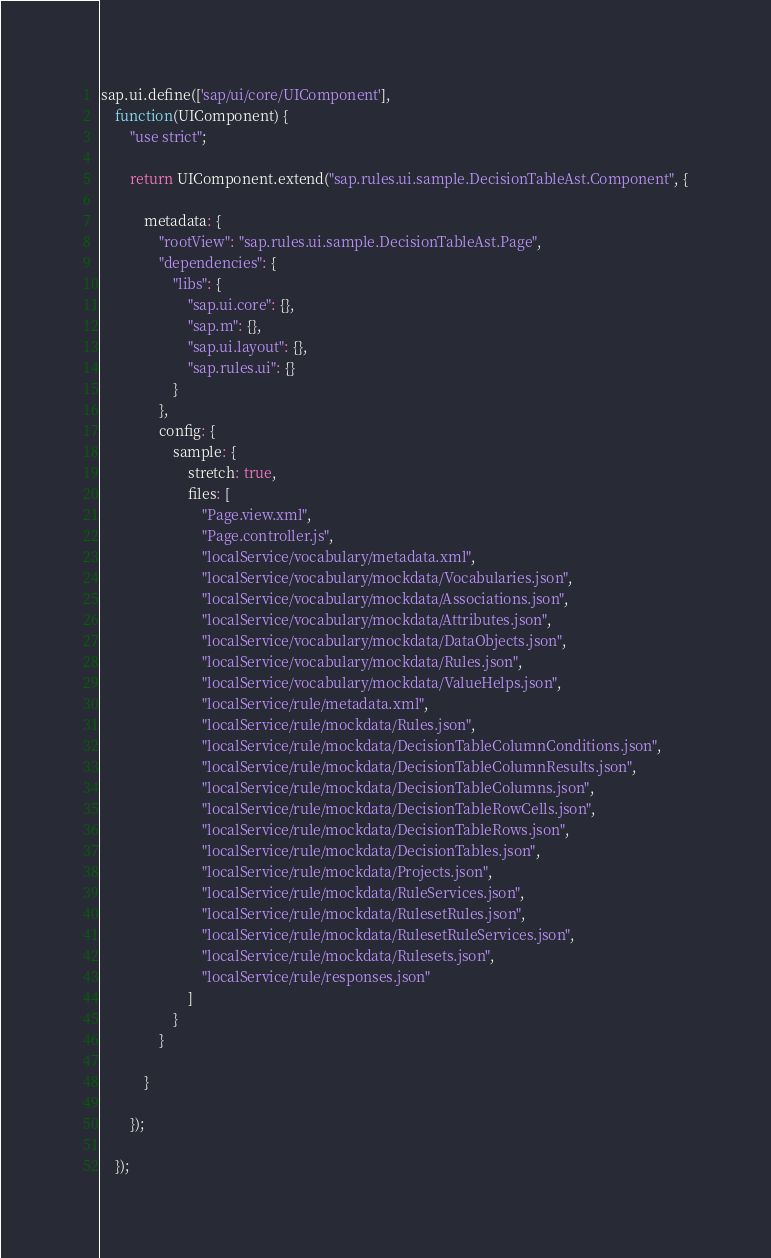<code> <loc_0><loc_0><loc_500><loc_500><_JavaScript_>sap.ui.define(['sap/ui/core/UIComponent'],
	function(UIComponent) {
		"use strict";

		return UIComponent.extend("sap.rules.ui.sample.DecisionTableAst.Component", {

			metadata: {
				"rootView": "sap.rules.ui.sample.DecisionTableAst.Page",
				"dependencies": {
					"libs": {
						"sap.ui.core": {},
						"sap.m": {},
						"sap.ui.layout": {},
						"sap.rules.ui": {}
					}
				},
				config: {
					sample: {
						stretch: true,
						files: [
							"Page.view.xml",
							"Page.controller.js",
							"localService/vocabulary/metadata.xml",
							"localService/vocabulary/mockdata/Vocabularies.json",
							"localService/vocabulary/mockdata/Associations.json",
							"localService/vocabulary/mockdata/Attributes.json",
							"localService/vocabulary/mockdata/DataObjects.json",
							"localService/vocabulary/mockdata/Rules.json",
							"localService/vocabulary/mockdata/ValueHelps.json",
							"localService/rule/metadata.xml",
							"localService/rule/mockdata/Rules.json",
							"localService/rule/mockdata/DecisionTableColumnConditions.json",
							"localService/rule/mockdata/DecisionTableColumnResults.json",
							"localService/rule/mockdata/DecisionTableColumns.json",
							"localService/rule/mockdata/DecisionTableRowCells.json",
							"localService/rule/mockdata/DecisionTableRows.json",
							"localService/rule/mockdata/DecisionTables.json",
							"localService/rule/mockdata/Projects.json",
							"localService/rule/mockdata/RuleServices.json",
							"localService/rule/mockdata/RulesetRules.json",
							"localService/rule/mockdata/RulesetRuleServices.json",
							"localService/rule/mockdata/Rulesets.json",
							"localService/rule/responses.json"
						] 
					}
				}

			}

		});

	});</code> 